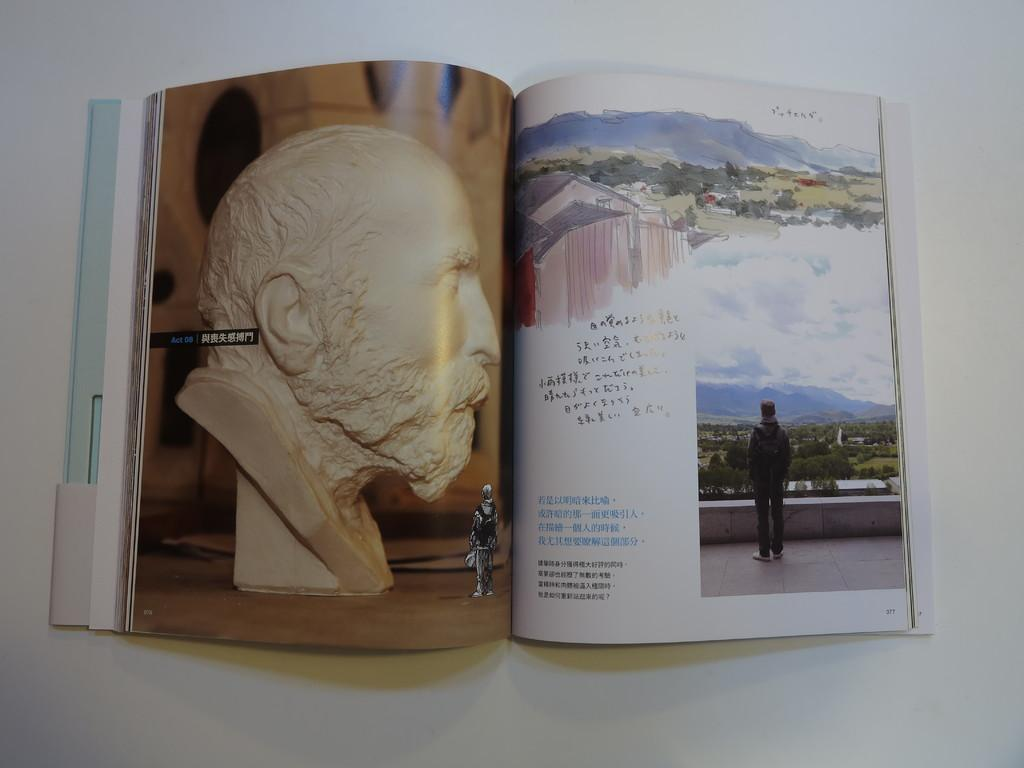Provide a one-sentence caption for the provided image. The book in Japanese language is opened to page 377. 